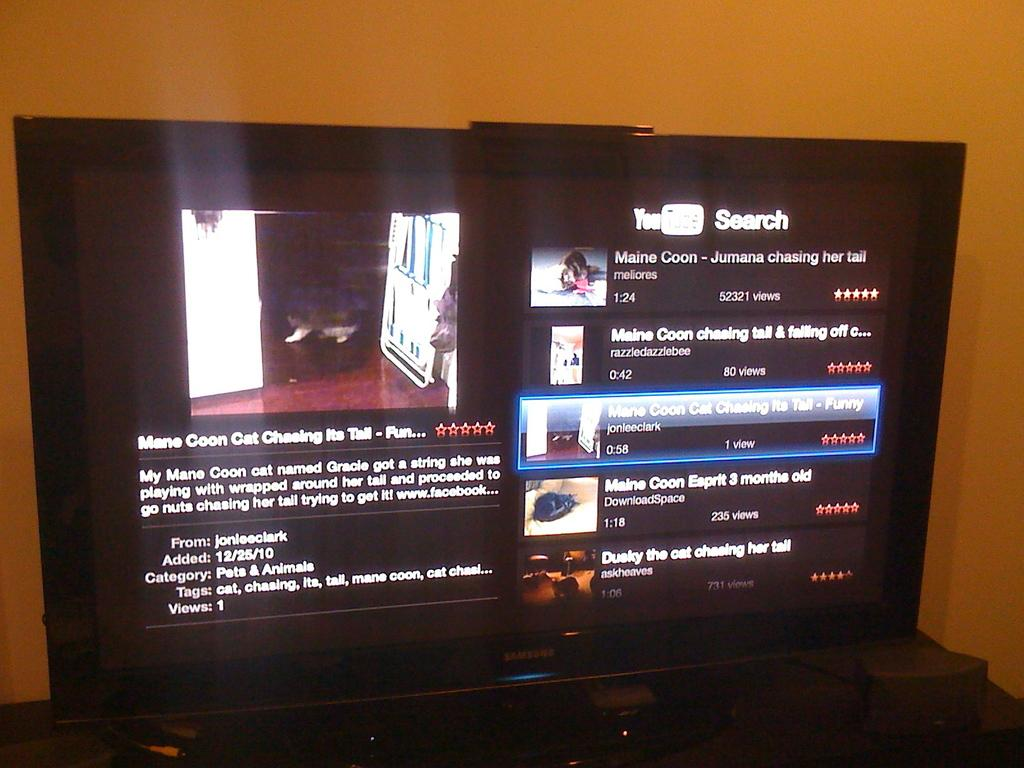<image>
Present a compact description of the photo's key features. Television that have youtube search on the right side 